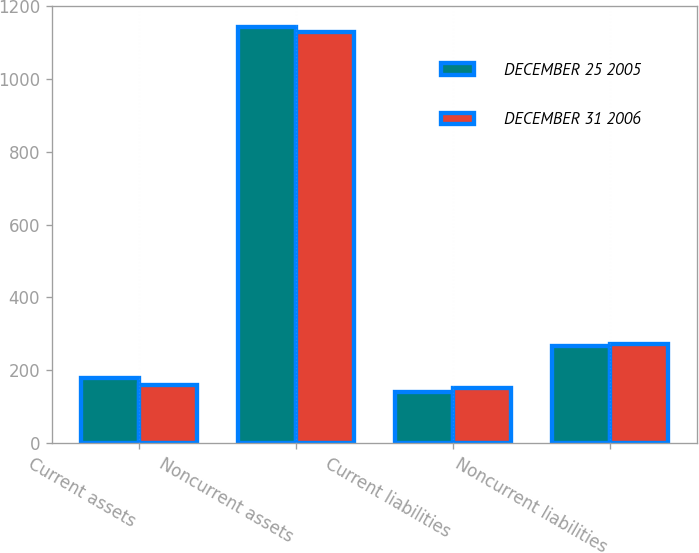Convert chart to OTSL. <chart><loc_0><loc_0><loc_500><loc_500><stacked_bar_chart><ecel><fcel>Current assets<fcel>Noncurrent assets<fcel>Current liabilities<fcel>Noncurrent liabilities<nl><fcel>DECEMBER 25 2005<fcel>180<fcel>1143<fcel>141<fcel>266<nl><fcel>DECEMBER 31 2006<fcel>160<fcel>1131<fcel>150<fcel>271<nl></chart> 